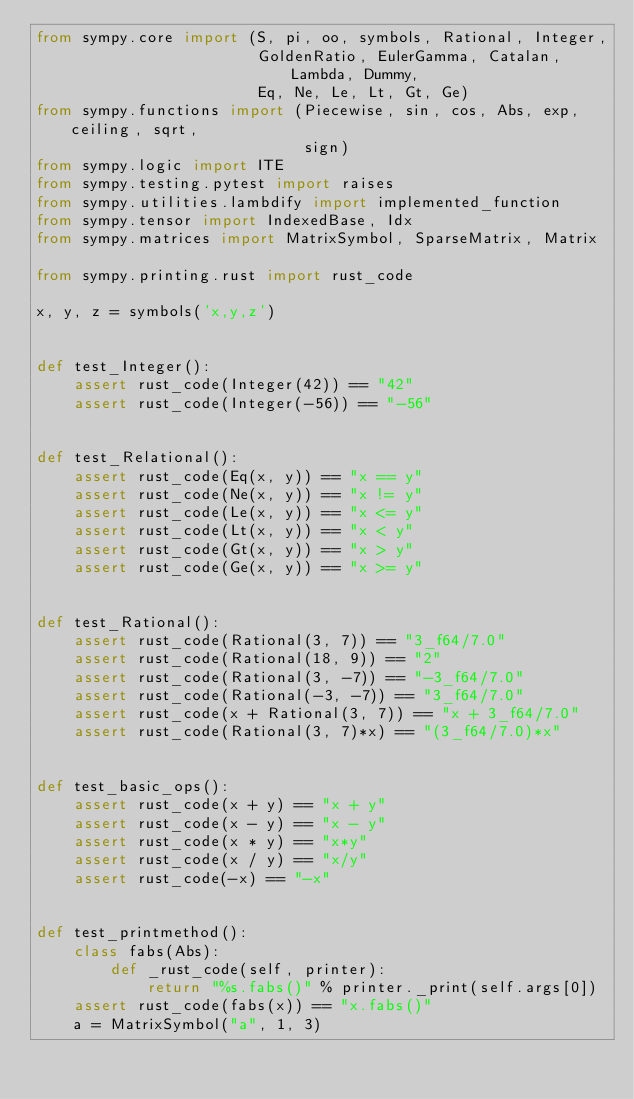Convert code to text. <code><loc_0><loc_0><loc_500><loc_500><_Python_>from sympy.core import (S, pi, oo, symbols, Rational, Integer,
                        GoldenRatio, EulerGamma, Catalan, Lambda, Dummy,
                        Eq, Ne, Le, Lt, Gt, Ge)
from sympy.functions import (Piecewise, sin, cos, Abs, exp, ceiling, sqrt,
                             sign)
from sympy.logic import ITE
from sympy.testing.pytest import raises
from sympy.utilities.lambdify import implemented_function
from sympy.tensor import IndexedBase, Idx
from sympy.matrices import MatrixSymbol, SparseMatrix, Matrix

from sympy.printing.rust import rust_code

x, y, z = symbols('x,y,z')


def test_Integer():
    assert rust_code(Integer(42)) == "42"
    assert rust_code(Integer(-56)) == "-56"


def test_Relational():
    assert rust_code(Eq(x, y)) == "x == y"
    assert rust_code(Ne(x, y)) == "x != y"
    assert rust_code(Le(x, y)) == "x <= y"
    assert rust_code(Lt(x, y)) == "x < y"
    assert rust_code(Gt(x, y)) == "x > y"
    assert rust_code(Ge(x, y)) == "x >= y"


def test_Rational():
    assert rust_code(Rational(3, 7)) == "3_f64/7.0"
    assert rust_code(Rational(18, 9)) == "2"
    assert rust_code(Rational(3, -7)) == "-3_f64/7.0"
    assert rust_code(Rational(-3, -7)) == "3_f64/7.0"
    assert rust_code(x + Rational(3, 7)) == "x + 3_f64/7.0"
    assert rust_code(Rational(3, 7)*x) == "(3_f64/7.0)*x"


def test_basic_ops():
    assert rust_code(x + y) == "x + y"
    assert rust_code(x - y) == "x - y"
    assert rust_code(x * y) == "x*y"
    assert rust_code(x / y) == "x/y"
    assert rust_code(-x) == "-x"


def test_printmethod():
    class fabs(Abs):
        def _rust_code(self, printer):
            return "%s.fabs()" % printer._print(self.args[0])
    assert rust_code(fabs(x)) == "x.fabs()"
    a = MatrixSymbol("a", 1, 3)</code> 